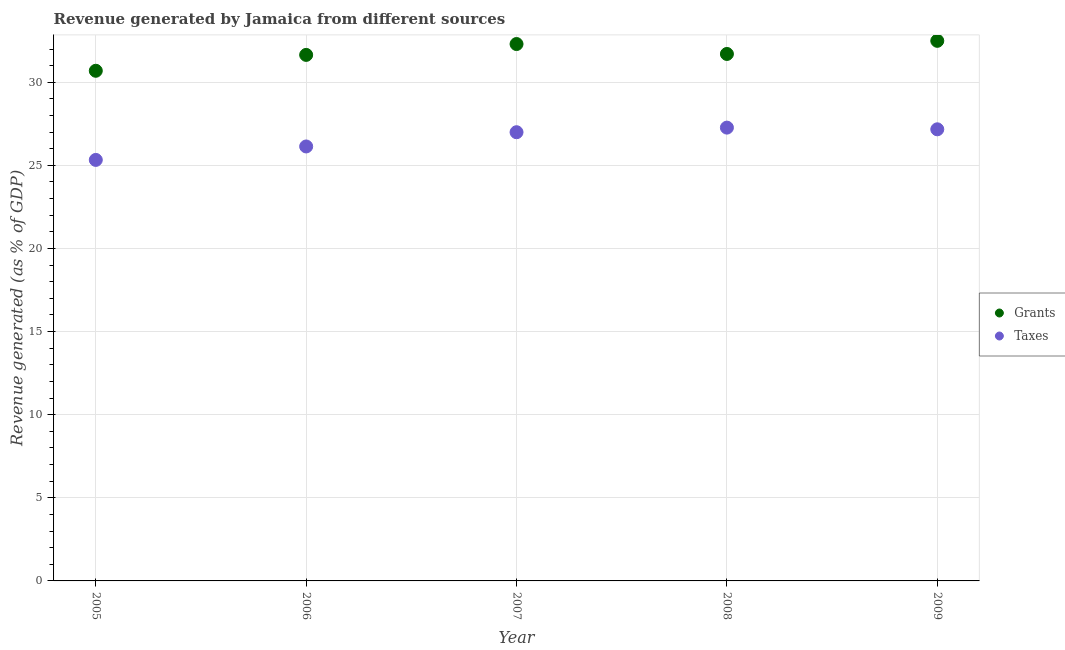How many different coloured dotlines are there?
Give a very brief answer. 2. Is the number of dotlines equal to the number of legend labels?
Offer a very short reply. Yes. What is the revenue generated by taxes in 2009?
Provide a succinct answer. 27.17. Across all years, what is the maximum revenue generated by taxes?
Provide a succinct answer. 27.27. Across all years, what is the minimum revenue generated by taxes?
Keep it short and to the point. 25.33. What is the total revenue generated by grants in the graph?
Your response must be concise. 158.83. What is the difference between the revenue generated by taxes in 2008 and that in 2009?
Provide a succinct answer. 0.1. What is the difference between the revenue generated by taxes in 2006 and the revenue generated by grants in 2009?
Keep it short and to the point. -6.35. What is the average revenue generated by taxes per year?
Provide a succinct answer. 26.58. In the year 2008, what is the difference between the revenue generated by taxes and revenue generated by grants?
Keep it short and to the point. -4.43. In how many years, is the revenue generated by grants greater than 22 %?
Make the answer very short. 5. What is the ratio of the revenue generated by taxes in 2005 to that in 2008?
Offer a very short reply. 0.93. What is the difference between the highest and the second highest revenue generated by grants?
Ensure brevity in your answer.  0.19. What is the difference between the highest and the lowest revenue generated by taxes?
Your response must be concise. 1.94. In how many years, is the revenue generated by grants greater than the average revenue generated by grants taken over all years?
Your answer should be compact. 2. Is the sum of the revenue generated by taxes in 2005 and 2009 greater than the maximum revenue generated by grants across all years?
Make the answer very short. Yes. Does the revenue generated by grants monotonically increase over the years?
Offer a terse response. No. Is the revenue generated by grants strictly greater than the revenue generated by taxes over the years?
Keep it short and to the point. Yes. How many dotlines are there?
Provide a short and direct response. 2. What is the difference between two consecutive major ticks on the Y-axis?
Your answer should be compact. 5. Does the graph contain any zero values?
Provide a succinct answer. No. What is the title of the graph?
Make the answer very short. Revenue generated by Jamaica from different sources. What is the label or title of the X-axis?
Provide a short and direct response. Year. What is the label or title of the Y-axis?
Provide a short and direct response. Revenue generated (as % of GDP). What is the Revenue generated (as % of GDP) of Grants in 2005?
Offer a terse response. 30.69. What is the Revenue generated (as % of GDP) of Taxes in 2005?
Your answer should be compact. 25.33. What is the Revenue generated (as % of GDP) in Grants in 2006?
Offer a very short reply. 31.65. What is the Revenue generated (as % of GDP) of Taxes in 2006?
Give a very brief answer. 26.14. What is the Revenue generated (as % of GDP) of Grants in 2007?
Offer a terse response. 32.3. What is the Revenue generated (as % of GDP) of Taxes in 2007?
Keep it short and to the point. 26.99. What is the Revenue generated (as % of GDP) in Grants in 2008?
Your answer should be compact. 31.7. What is the Revenue generated (as % of GDP) of Taxes in 2008?
Offer a very short reply. 27.27. What is the Revenue generated (as % of GDP) of Grants in 2009?
Make the answer very short. 32.49. What is the Revenue generated (as % of GDP) in Taxes in 2009?
Give a very brief answer. 27.17. Across all years, what is the maximum Revenue generated (as % of GDP) of Grants?
Keep it short and to the point. 32.49. Across all years, what is the maximum Revenue generated (as % of GDP) in Taxes?
Your answer should be compact. 27.27. Across all years, what is the minimum Revenue generated (as % of GDP) of Grants?
Give a very brief answer. 30.69. Across all years, what is the minimum Revenue generated (as % of GDP) of Taxes?
Ensure brevity in your answer.  25.33. What is the total Revenue generated (as % of GDP) of Grants in the graph?
Your response must be concise. 158.83. What is the total Revenue generated (as % of GDP) of Taxes in the graph?
Keep it short and to the point. 132.9. What is the difference between the Revenue generated (as % of GDP) of Grants in 2005 and that in 2006?
Offer a very short reply. -0.96. What is the difference between the Revenue generated (as % of GDP) in Taxes in 2005 and that in 2006?
Offer a terse response. -0.81. What is the difference between the Revenue generated (as % of GDP) of Grants in 2005 and that in 2007?
Keep it short and to the point. -1.61. What is the difference between the Revenue generated (as % of GDP) of Taxes in 2005 and that in 2007?
Offer a very short reply. -1.67. What is the difference between the Revenue generated (as % of GDP) of Grants in 2005 and that in 2008?
Your response must be concise. -1.01. What is the difference between the Revenue generated (as % of GDP) of Taxes in 2005 and that in 2008?
Your answer should be compact. -1.94. What is the difference between the Revenue generated (as % of GDP) of Grants in 2005 and that in 2009?
Provide a short and direct response. -1.8. What is the difference between the Revenue generated (as % of GDP) of Taxes in 2005 and that in 2009?
Offer a terse response. -1.84. What is the difference between the Revenue generated (as % of GDP) in Grants in 2006 and that in 2007?
Your response must be concise. -0.65. What is the difference between the Revenue generated (as % of GDP) of Taxes in 2006 and that in 2007?
Offer a terse response. -0.86. What is the difference between the Revenue generated (as % of GDP) of Grants in 2006 and that in 2008?
Make the answer very short. -0.06. What is the difference between the Revenue generated (as % of GDP) of Taxes in 2006 and that in 2008?
Your response must be concise. -1.13. What is the difference between the Revenue generated (as % of GDP) in Grants in 2006 and that in 2009?
Provide a short and direct response. -0.85. What is the difference between the Revenue generated (as % of GDP) of Taxes in 2006 and that in 2009?
Offer a terse response. -1.03. What is the difference between the Revenue generated (as % of GDP) of Grants in 2007 and that in 2008?
Offer a terse response. 0.6. What is the difference between the Revenue generated (as % of GDP) in Taxes in 2007 and that in 2008?
Provide a short and direct response. -0.28. What is the difference between the Revenue generated (as % of GDP) of Grants in 2007 and that in 2009?
Give a very brief answer. -0.19. What is the difference between the Revenue generated (as % of GDP) in Taxes in 2007 and that in 2009?
Your response must be concise. -0.17. What is the difference between the Revenue generated (as % of GDP) of Grants in 2008 and that in 2009?
Offer a terse response. -0.79. What is the difference between the Revenue generated (as % of GDP) in Taxes in 2008 and that in 2009?
Provide a short and direct response. 0.1. What is the difference between the Revenue generated (as % of GDP) of Grants in 2005 and the Revenue generated (as % of GDP) of Taxes in 2006?
Your answer should be very brief. 4.55. What is the difference between the Revenue generated (as % of GDP) in Grants in 2005 and the Revenue generated (as % of GDP) in Taxes in 2007?
Offer a terse response. 3.7. What is the difference between the Revenue generated (as % of GDP) in Grants in 2005 and the Revenue generated (as % of GDP) in Taxes in 2008?
Your answer should be compact. 3.42. What is the difference between the Revenue generated (as % of GDP) of Grants in 2005 and the Revenue generated (as % of GDP) of Taxes in 2009?
Ensure brevity in your answer.  3.52. What is the difference between the Revenue generated (as % of GDP) of Grants in 2006 and the Revenue generated (as % of GDP) of Taxes in 2007?
Offer a very short reply. 4.65. What is the difference between the Revenue generated (as % of GDP) in Grants in 2006 and the Revenue generated (as % of GDP) in Taxes in 2008?
Make the answer very short. 4.37. What is the difference between the Revenue generated (as % of GDP) of Grants in 2006 and the Revenue generated (as % of GDP) of Taxes in 2009?
Keep it short and to the point. 4.48. What is the difference between the Revenue generated (as % of GDP) in Grants in 2007 and the Revenue generated (as % of GDP) in Taxes in 2008?
Ensure brevity in your answer.  5.03. What is the difference between the Revenue generated (as % of GDP) in Grants in 2007 and the Revenue generated (as % of GDP) in Taxes in 2009?
Make the answer very short. 5.13. What is the difference between the Revenue generated (as % of GDP) in Grants in 2008 and the Revenue generated (as % of GDP) in Taxes in 2009?
Offer a very short reply. 4.53. What is the average Revenue generated (as % of GDP) of Grants per year?
Ensure brevity in your answer.  31.77. What is the average Revenue generated (as % of GDP) in Taxes per year?
Provide a succinct answer. 26.58. In the year 2005, what is the difference between the Revenue generated (as % of GDP) in Grants and Revenue generated (as % of GDP) in Taxes?
Provide a succinct answer. 5.36. In the year 2006, what is the difference between the Revenue generated (as % of GDP) of Grants and Revenue generated (as % of GDP) of Taxes?
Make the answer very short. 5.51. In the year 2007, what is the difference between the Revenue generated (as % of GDP) in Grants and Revenue generated (as % of GDP) in Taxes?
Make the answer very short. 5.3. In the year 2008, what is the difference between the Revenue generated (as % of GDP) in Grants and Revenue generated (as % of GDP) in Taxes?
Your answer should be very brief. 4.43. In the year 2009, what is the difference between the Revenue generated (as % of GDP) of Grants and Revenue generated (as % of GDP) of Taxes?
Your response must be concise. 5.32. What is the ratio of the Revenue generated (as % of GDP) of Grants in 2005 to that in 2006?
Keep it short and to the point. 0.97. What is the ratio of the Revenue generated (as % of GDP) in Grants in 2005 to that in 2007?
Offer a terse response. 0.95. What is the ratio of the Revenue generated (as % of GDP) of Taxes in 2005 to that in 2007?
Give a very brief answer. 0.94. What is the ratio of the Revenue generated (as % of GDP) of Grants in 2005 to that in 2008?
Ensure brevity in your answer.  0.97. What is the ratio of the Revenue generated (as % of GDP) in Taxes in 2005 to that in 2008?
Offer a terse response. 0.93. What is the ratio of the Revenue generated (as % of GDP) of Grants in 2005 to that in 2009?
Your answer should be compact. 0.94. What is the ratio of the Revenue generated (as % of GDP) of Taxes in 2005 to that in 2009?
Your response must be concise. 0.93. What is the ratio of the Revenue generated (as % of GDP) in Grants in 2006 to that in 2007?
Your response must be concise. 0.98. What is the ratio of the Revenue generated (as % of GDP) in Taxes in 2006 to that in 2007?
Keep it short and to the point. 0.97. What is the ratio of the Revenue generated (as % of GDP) of Taxes in 2006 to that in 2008?
Offer a terse response. 0.96. What is the ratio of the Revenue generated (as % of GDP) in Grants in 2006 to that in 2009?
Your answer should be compact. 0.97. What is the ratio of the Revenue generated (as % of GDP) in Taxes in 2006 to that in 2009?
Give a very brief answer. 0.96. What is the ratio of the Revenue generated (as % of GDP) in Grants in 2007 to that in 2008?
Make the answer very short. 1.02. What is the ratio of the Revenue generated (as % of GDP) in Grants in 2007 to that in 2009?
Ensure brevity in your answer.  0.99. What is the ratio of the Revenue generated (as % of GDP) in Taxes in 2007 to that in 2009?
Keep it short and to the point. 0.99. What is the ratio of the Revenue generated (as % of GDP) in Grants in 2008 to that in 2009?
Provide a short and direct response. 0.98. What is the ratio of the Revenue generated (as % of GDP) of Taxes in 2008 to that in 2009?
Keep it short and to the point. 1. What is the difference between the highest and the second highest Revenue generated (as % of GDP) of Grants?
Your answer should be very brief. 0.19. What is the difference between the highest and the second highest Revenue generated (as % of GDP) in Taxes?
Give a very brief answer. 0.1. What is the difference between the highest and the lowest Revenue generated (as % of GDP) of Grants?
Offer a very short reply. 1.8. What is the difference between the highest and the lowest Revenue generated (as % of GDP) of Taxes?
Your response must be concise. 1.94. 